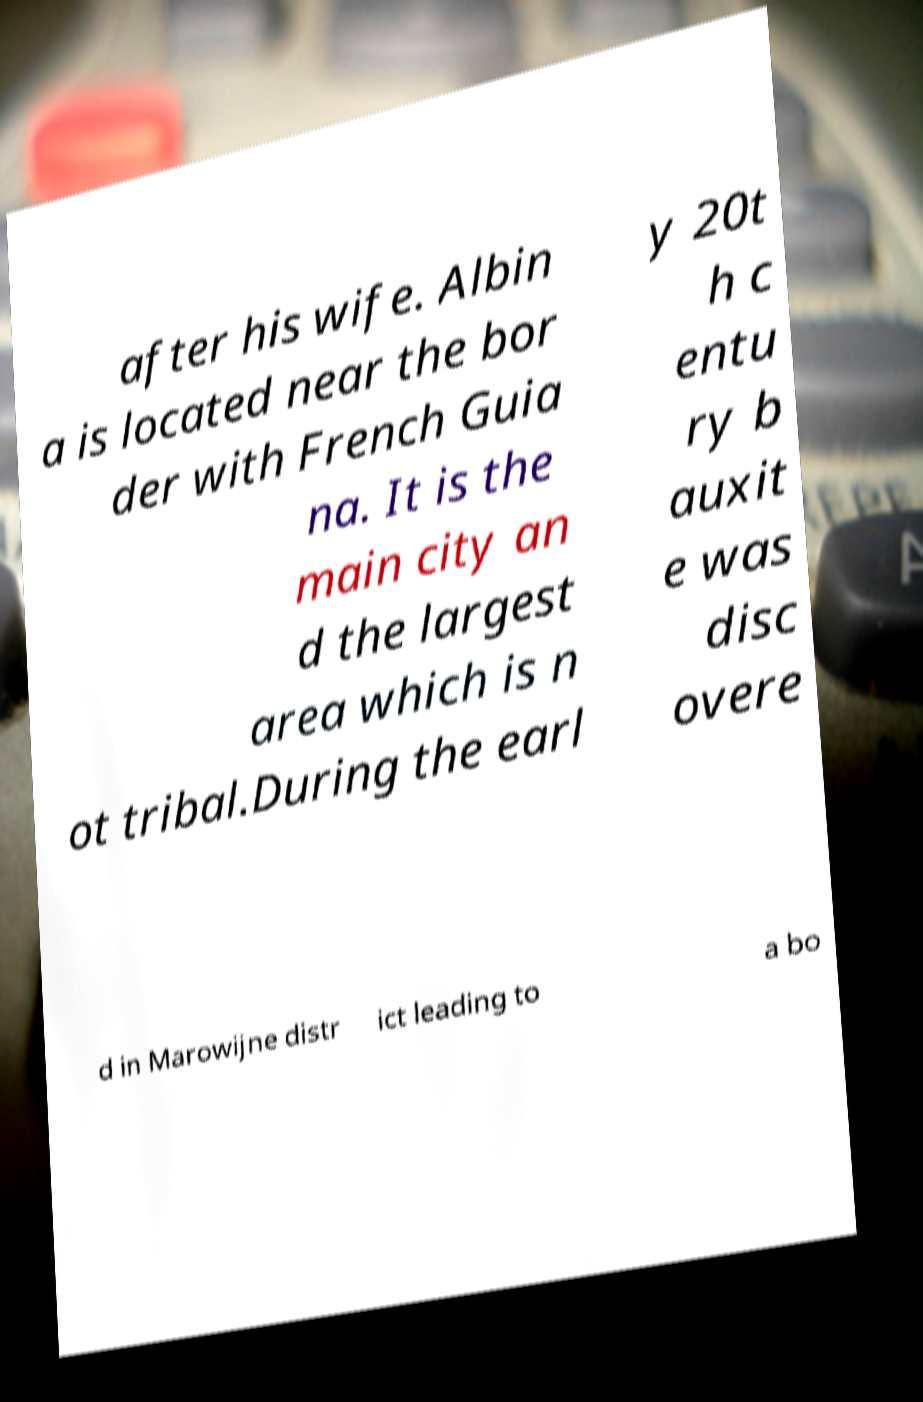Could you assist in decoding the text presented in this image and type it out clearly? after his wife. Albin a is located near the bor der with French Guia na. It is the main city an d the largest area which is n ot tribal.During the earl y 20t h c entu ry b auxit e was disc overe d in Marowijne distr ict leading to a bo 